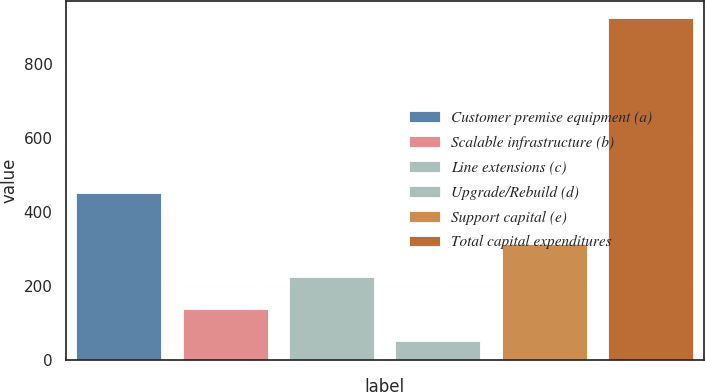<chart> <loc_0><loc_0><loc_500><loc_500><bar_chart><fcel>Customer premise equipment (a)<fcel>Scalable infrastructure (b)<fcel>Line extensions (c)<fcel>Upgrade/Rebuild (d)<fcel>Support capital (e)<fcel>Total capital expenditures<nl><fcel>451<fcel>136.5<fcel>224<fcel>49<fcel>311.5<fcel>924<nl></chart> 